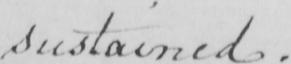Transcribe the text shown in this historical manuscript line. sustained . 